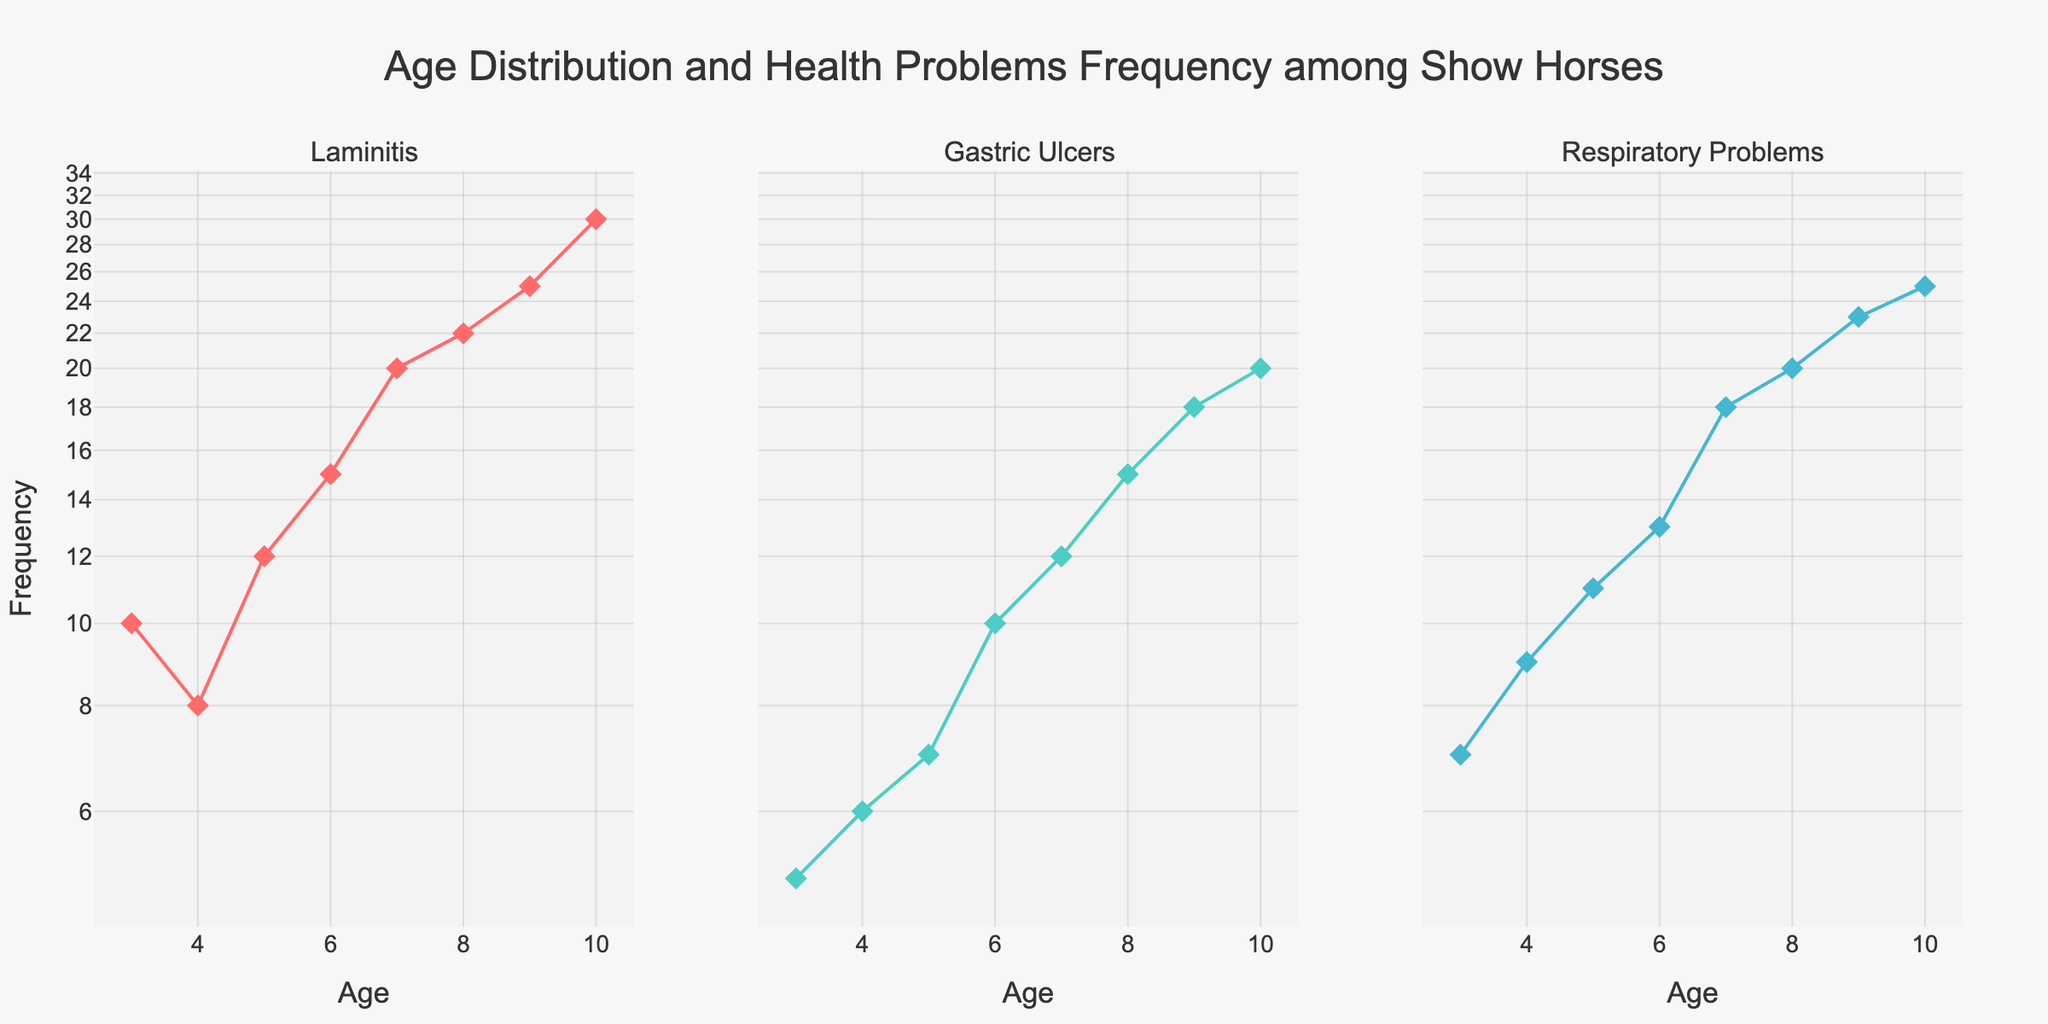What is the title of the figure? The title is usually found at the top of the figure and provides a brief description of what the figure is about. In this case, the title is "Age Distribution and Health Problems Frequency among Show Horses."
Answer: Age Distribution and Health Problems Frequency among Show Horses How many subplots are in the figure? By observing the figure, it's clear that there are three distinct subplots, each representing a different health problem: Laminitis, Gastric Ulcers, and Respiratory Problems.
Answer: Three Which health problem shows the highest frequency for a 10-year-old horse? To find this, look at the data points for 10-year-old horses across all three subplots. The subplot for Laminitis has the highest y-value at age 10.
Answer: Laminitis What is the common Y-axis type for all subplots? By examining the Y-axis labels and their scale on all three subplots, it's clear that they share a logarithmic scale instead of a linear one.
Answer: Logarithmic How does the frequency of Respiratory Problems at age 7 compare to Gastric Ulcers at the same age? To compare, look at the subplots for both Respiratory Problems and Gastric Ulcers at age 7. Respiratory Problems have a higher frequency compared to Gastric Ulcers according to their markers' positions on the Y-axis.
Answer: Higher What trend do you observe in the frequency of Laminitis as the age of the horse increases? Observe the line plot in the Laminitis subplot; it consistently increases as the age of the horse increases, indicating a rising frequency with age.
Answer: Increasing Calculate the total frequency of all health problems at age 8. To find the total, add the frequencies of Laminitis (22), Gastric Ulcers (15), and Respiratory Problems (20) at age 8. The sum is 22 + 15 + 20 = 57.
Answer: 57 Which health problem shows the least change in frequency between ages 3 and 10? By comparing the slopes and differences in each subplot between ages 3 and 10, Gastric Ulcers show the least increase in frequency, indicating the least change.
Answer: Gastric Ulcers How many data points are there in the Laminitis subplot? Count the discrete markers (diamonds) in the Laminitis subplot, representing the data points. Each age from 3 to 10 has one marker, totaling 8.
Answer: Eight What color is used to represent Respiratory Problems in the subplots? Identifying the line and marker color for Respiratory Problems, which are shown in blue color.
Answer: Blue 